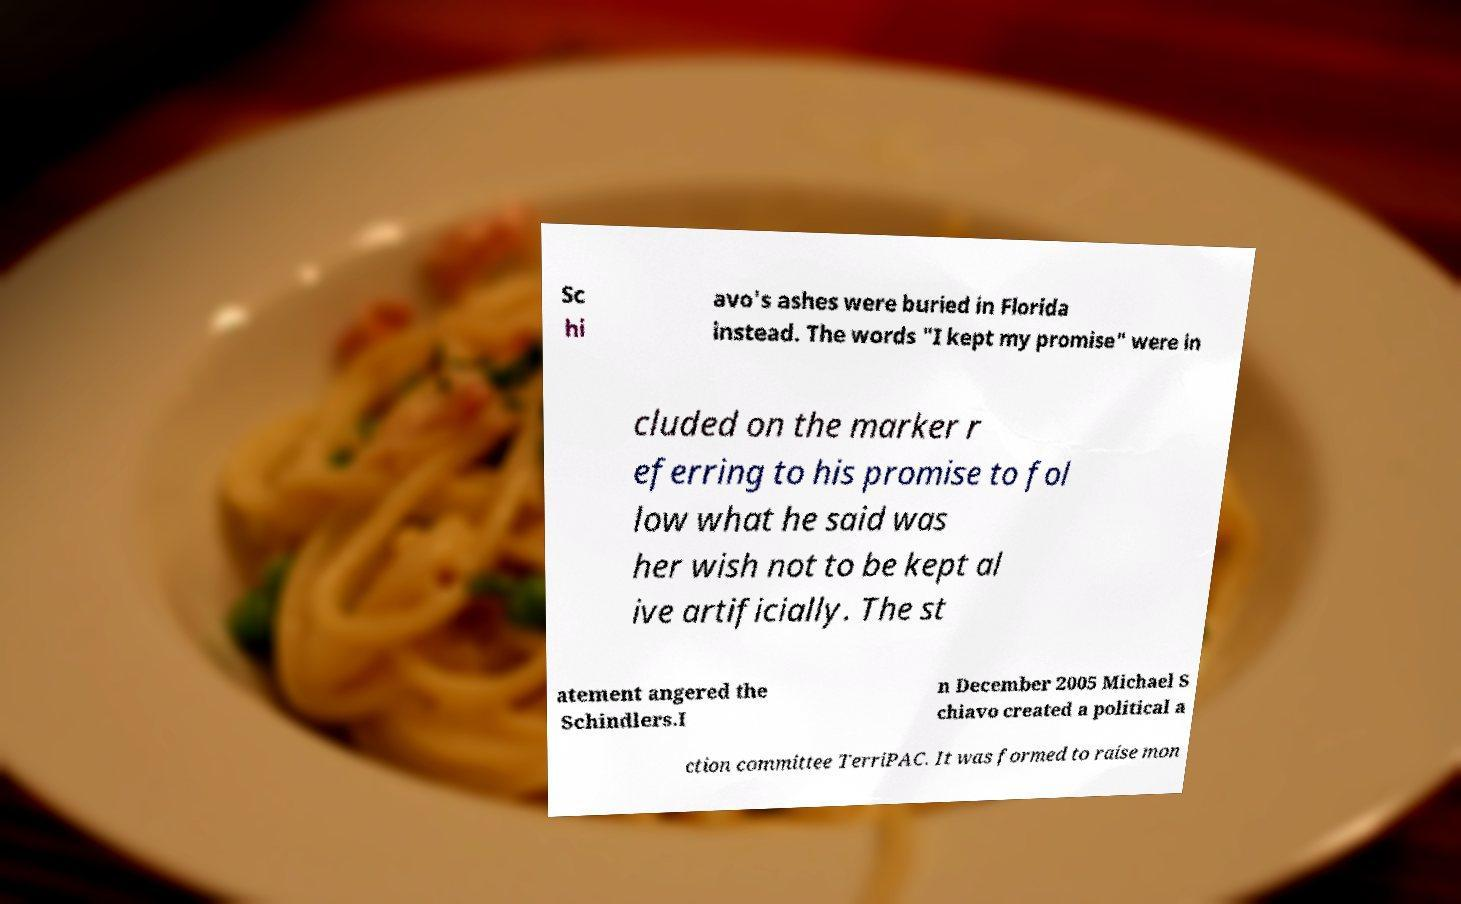Please identify and transcribe the text found in this image. Sc hi avo's ashes were buried in Florida instead. The words "I kept my promise" were in cluded on the marker r eferring to his promise to fol low what he said was her wish not to be kept al ive artificially. The st atement angered the Schindlers.I n December 2005 Michael S chiavo created a political a ction committee TerriPAC. It was formed to raise mon 